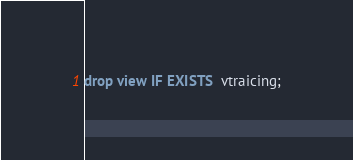Convert code to text. <code><loc_0><loc_0><loc_500><loc_500><_SQL_>drop view IF EXISTS  vtraicing;</code> 